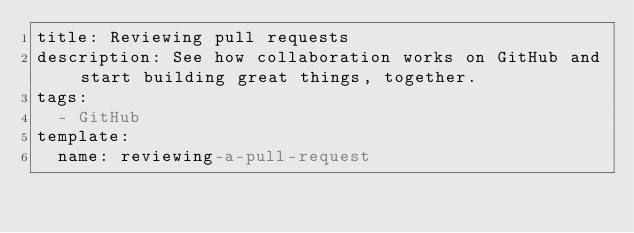<code> <loc_0><loc_0><loc_500><loc_500><_YAML_>title: Reviewing pull requests
description: See how collaboration works on GitHub and start building great things, together.
tags:
  - GitHub
template:
  name: reviewing-a-pull-request</code> 